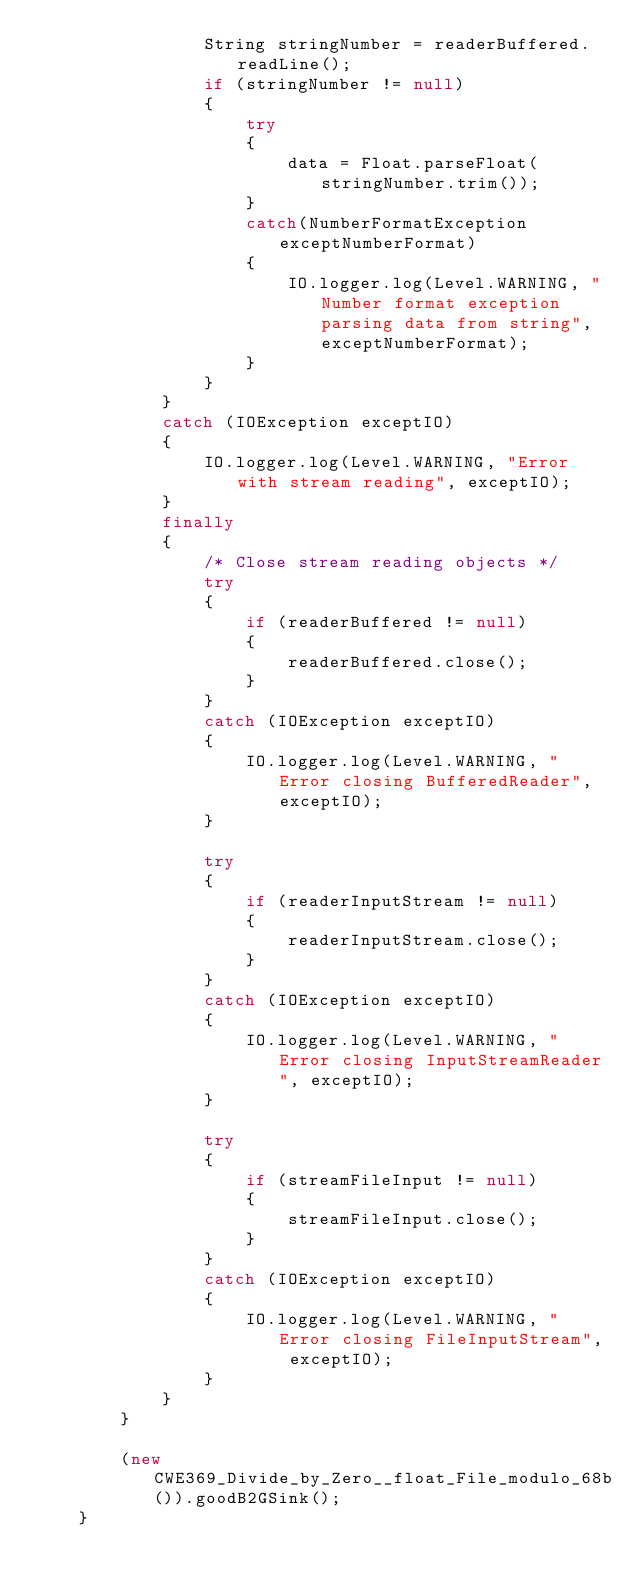<code> <loc_0><loc_0><loc_500><loc_500><_Java_>                String stringNumber = readerBuffered.readLine();
                if (stringNumber != null)
                {
                    try
                    {
                        data = Float.parseFloat(stringNumber.trim());
                    }
                    catch(NumberFormatException exceptNumberFormat)
                    {
                        IO.logger.log(Level.WARNING, "Number format exception parsing data from string", exceptNumberFormat);
                    }
                }
            }
            catch (IOException exceptIO)
            {
                IO.logger.log(Level.WARNING, "Error with stream reading", exceptIO);
            }
            finally
            {
                /* Close stream reading objects */
                try
                {
                    if (readerBuffered != null)
                    {
                        readerBuffered.close();
                    }
                }
                catch (IOException exceptIO)
                {
                    IO.logger.log(Level.WARNING, "Error closing BufferedReader", exceptIO);
                }

                try
                {
                    if (readerInputStream != null)
                    {
                        readerInputStream.close();
                    }
                }
                catch (IOException exceptIO)
                {
                    IO.logger.log(Level.WARNING, "Error closing InputStreamReader", exceptIO);
                }

                try
                {
                    if (streamFileInput != null)
                    {
                        streamFileInput.close();
                    }
                }
                catch (IOException exceptIO)
                {
                    IO.logger.log(Level.WARNING, "Error closing FileInputStream", exceptIO);
                }
            }
        }

        (new CWE369_Divide_by_Zero__float_File_modulo_68b()).goodB2GSink();
    }
</code> 